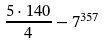<formula> <loc_0><loc_0><loc_500><loc_500>\frac { 5 \cdot 1 4 0 } { 4 } - 7 ^ { 3 5 7 }</formula> 